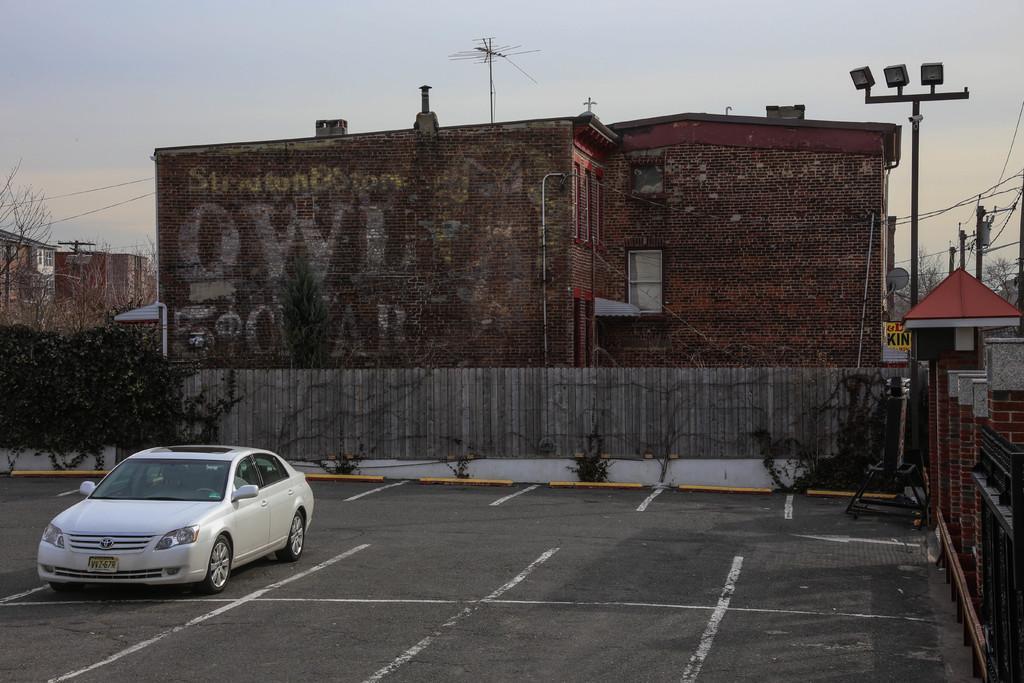Please provide a concise description of this image. In this picture I can observe a car parked in the parking lot on the left side. I can observe building in the middle of the picture. On the left side I can observe some plants. In the background there is sky. 